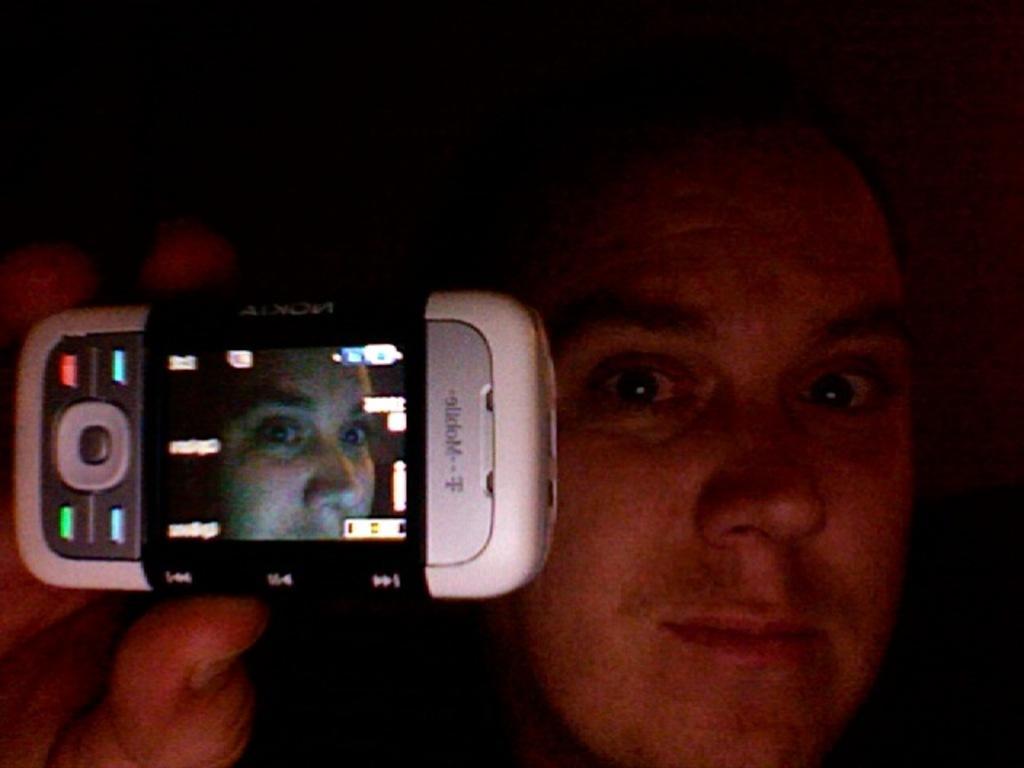Describe this image in one or two sentences. In this image the man is holding a mobile. 